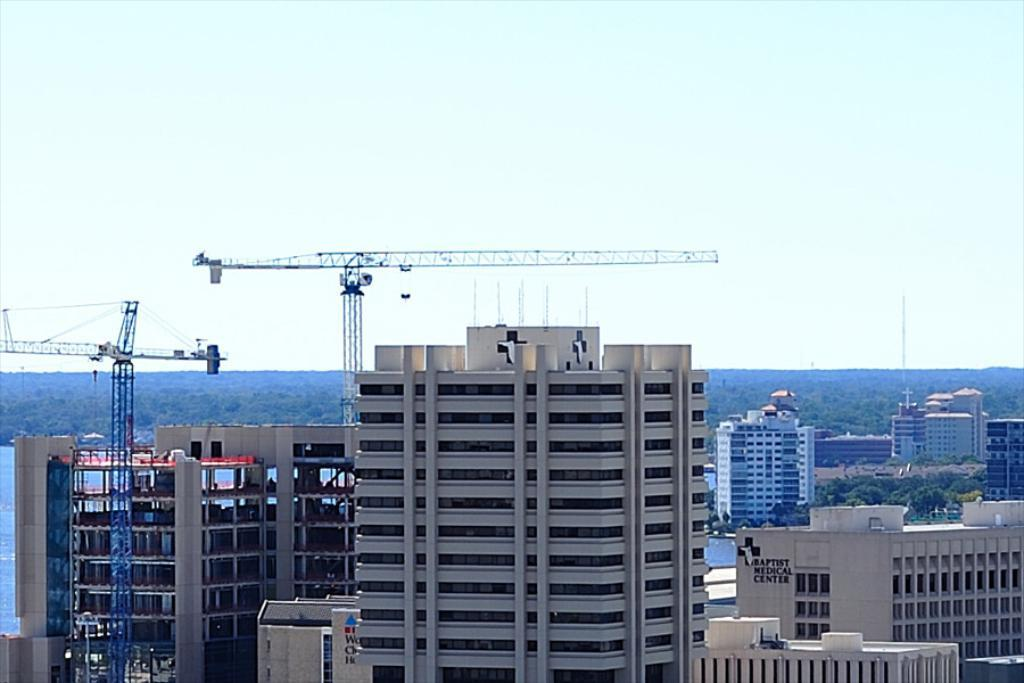What type of structures can be seen in the image? There are buildings in the image. What are the large machines near the buildings? There are cranes in the image. What type of vegetation is present in the image? There are trees in the image. What natural element is visible in the image? There is water visible in the image. How would you describe the sky in the image? The sky is blue and cloudy. What type of grape can be seen hanging from the crane in the image? There is no grape present in the image, and grapes do not hang from cranes. 